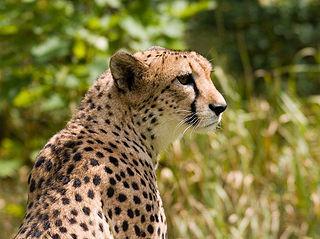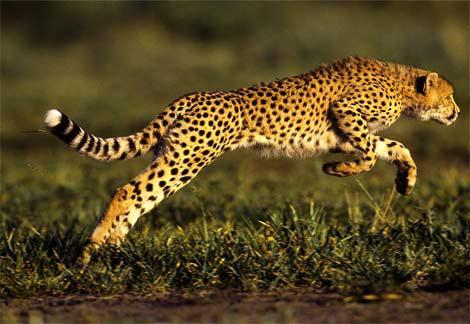The first image is the image on the left, the second image is the image on the right. For the images displayed, is the sentence "One image contains one cheetah, with its neck turned to gaze rightward, and the other image shows one cheetah in profile in a rightward bounding pose, with at least its front paws off the ground." factually correct? Answer yes or no. Yes. The first image is the image on the left, the second image is the image on the right. Considering the images on both sides, is "One cheetah's front paws are off the ground." valid? Answer yes or no. Yes. 